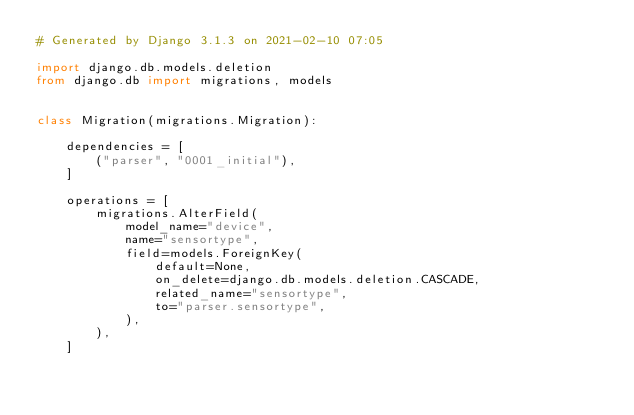Convert code to text. <code><loc_0><loc_0><loc_500><loc_500><_Python_># Generated by Django 3.1.3 on 2021-02-10 07:05

import django.db.models.deletion
from django.db import migrations, models


class Migration(migrations.Migration):

    dependencies = [
        ("parser", "0001_initial"),
    ]

    operations = [
        migrations.AlterField(
            model_name="device",
            name="sensortype",
            field=models.ForeignKey(
                default=None,
                on_delete=django.db.models.deletion.CASCADE,
                related_name="sensortype",
                to="parser.sensortype",
            ),
        ),
    ]
</code> 